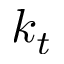<formula> <loc_0><loc_0><loc_500><loc_500>k _ { t }</formula> 